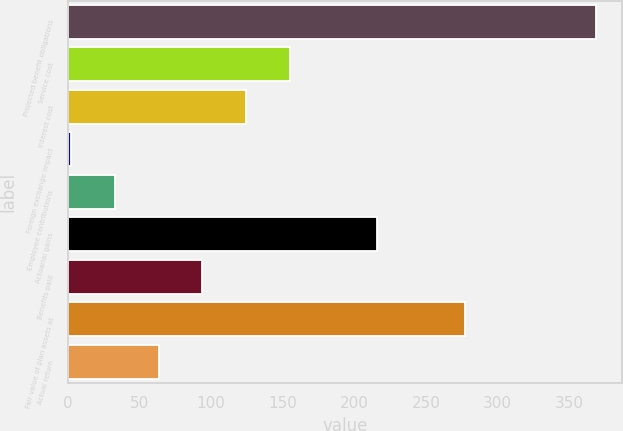<chart> <loc_0><loc_0><loc_500><loc_500><bar_chart><fcel>Projected benefit obligations<fcel>Service cost<fcel>Interest cost<fcel>Foreign exchange impact<fcel>Employee contributions<fcel>Actuarial gains<fcel>Benefits paid<fcel>Fair value of plan assets at<fcel>Actual return<nl><fcel>368.68<fcel>154.9<fcel>124.36<fcel>2.2<fcel>32.74<fcel>215.98<fcel>93.82<fcel>277.06<fcel>63.28<nl></chart> 